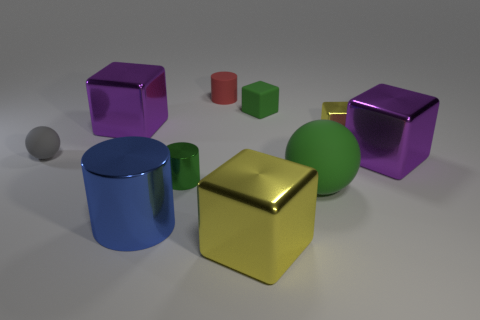Subtract all matte cubes. How many cubes are left? 4 Subtract all green balls. How many balls are left? 1 Subtract all cylinders. How many objects are left? 7 Subtract all green cubes. How many gray balls are left? 1 Add 1 matte blocks. How many matte blocks are left? 2 Add 2 large yellow cubes. How many large yellow cubes exist? 3 Subtract 0 brown spheres. How many objects are left? 10 Subtract 1 balls. How many balls are left? 1 Subtract all gray balls. Subtract all cyan cylinders. How many balls are left? 1 Subtract all tiny cyan metal things. Subtract all small green metal cylinders. How many objects are left? 9 